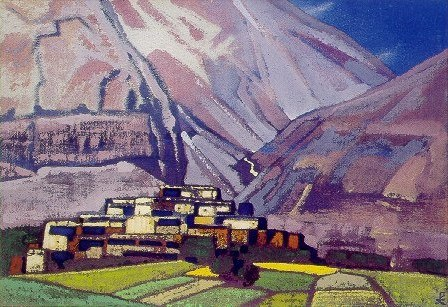Discuss the artistic techniques used in this painting. The artist employs an impressionistic technique characterized by quick, thick brush strokes that add depth and texture to the landscape. The choice of contrasting colors and the interplay between light and shadow enhance the three-dimensional feel of the scene. The composition is structured yet appears spontaneous, a hallmark of impressionism, intended to capture a moment in time with all its emotional and sensory impressions rather than mere photographic detail. 